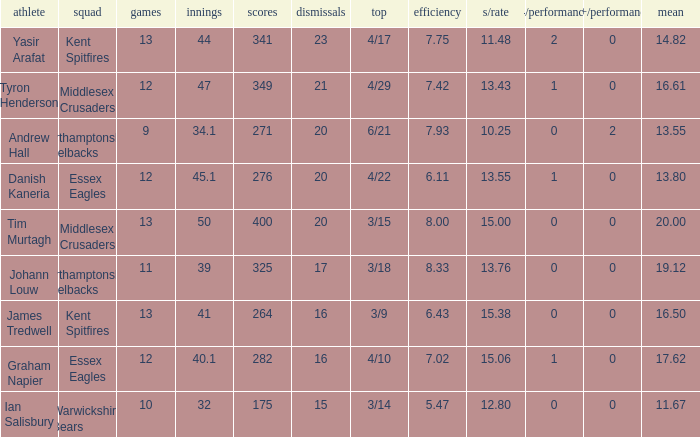Name the most 4/inns 2.0. 